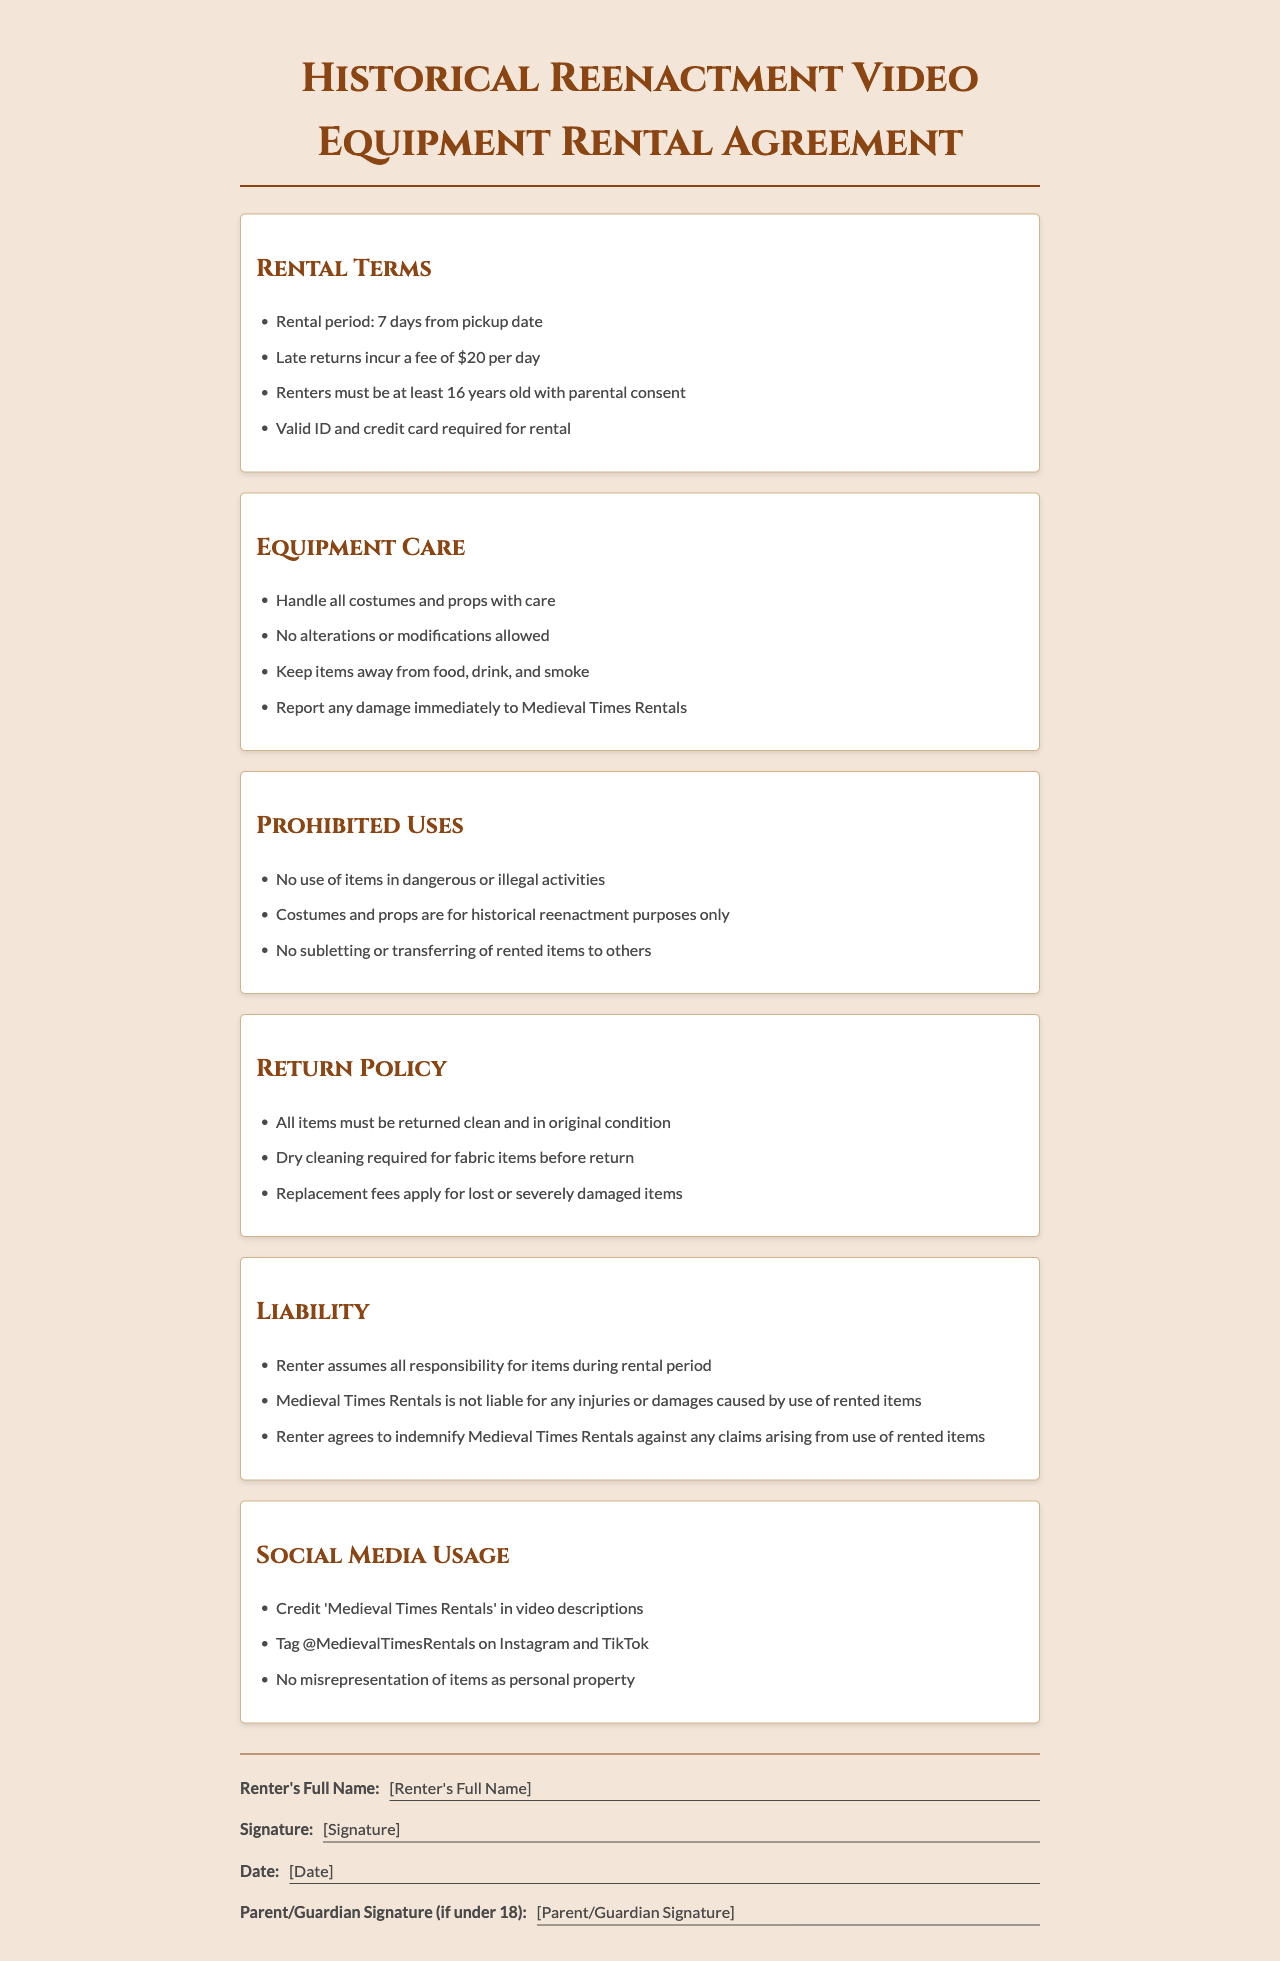What is the rental period? The rental period is specified as the duration from the pickup date, which is 7 days.
Answer: 7 days What is the late return fee? The document states that there is a fee for late returns, which is $20 per day.
Answer: $20 per day What age must renters be with parental consent? According to the terms, renters must be at least 16 years old with parental consent.
Answer: 16 years old What must renters do if damage occurs? The policy requires that any damage must be reported immediately to Medieval Times Rentals.
Answer: Report immediately Are alterations allowed on rented costumes and props? The document explicitly states that no alterations or modifications are allowed.
Answer: No alterations What happens if items are returned dirty? The return policy requires items to be returned clean and in original condition, indicating that dry cleaning is needed for fabric items before return.
Answer: Dry cleaning required Can rented items be used for illegal activities? The document states that no use of items in dangerous or illegal activities is allowed.
Answer: No What must renters credit in their video descriptions? The policy requires that renters credit 'Medieval Times Rentals' in their video descriptions.
Answer: Medieval Times Rentals What should renters do if they are under 18? Renters under 18 must have a parent or guardian sign the rental agreement.
Answer: Parent/Guardian Signature 